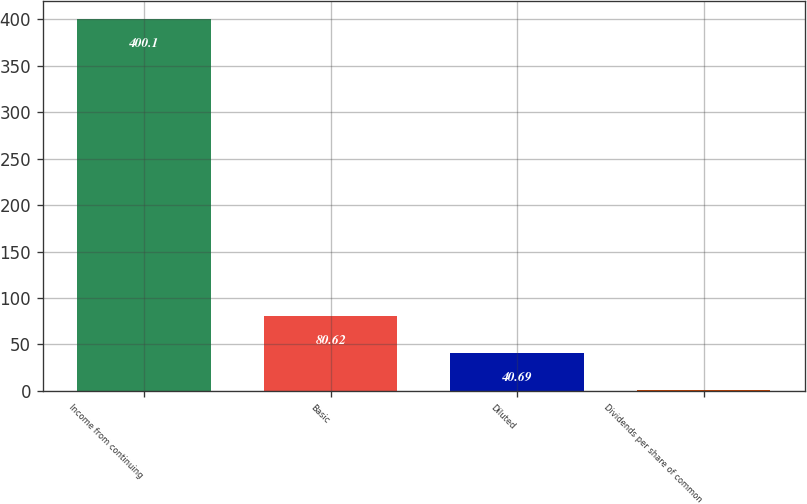Convert chart to OTSL. <chart><loc_0><loc_0><loc_500><loc_500><bar_chart><fcel>Income from continuing<fcel>Basic<fcel>Diluted<fcel>Dividends per share of common<nl><fcel>400.1<fcel>80.62<fcel>40.69<fcel>0.76<nl></chart> 